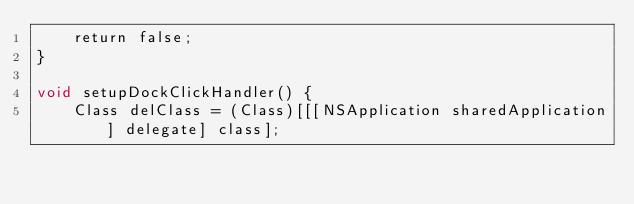Convert code to text. <code><loc_0><loc_0><loc_500><loc_500><_ObjectiveC_>    return false;
}

void setupDockClickHandler() {
    Class delClass = (Class)[[[NSApplication sharedApplication] delegate] class];</code> 